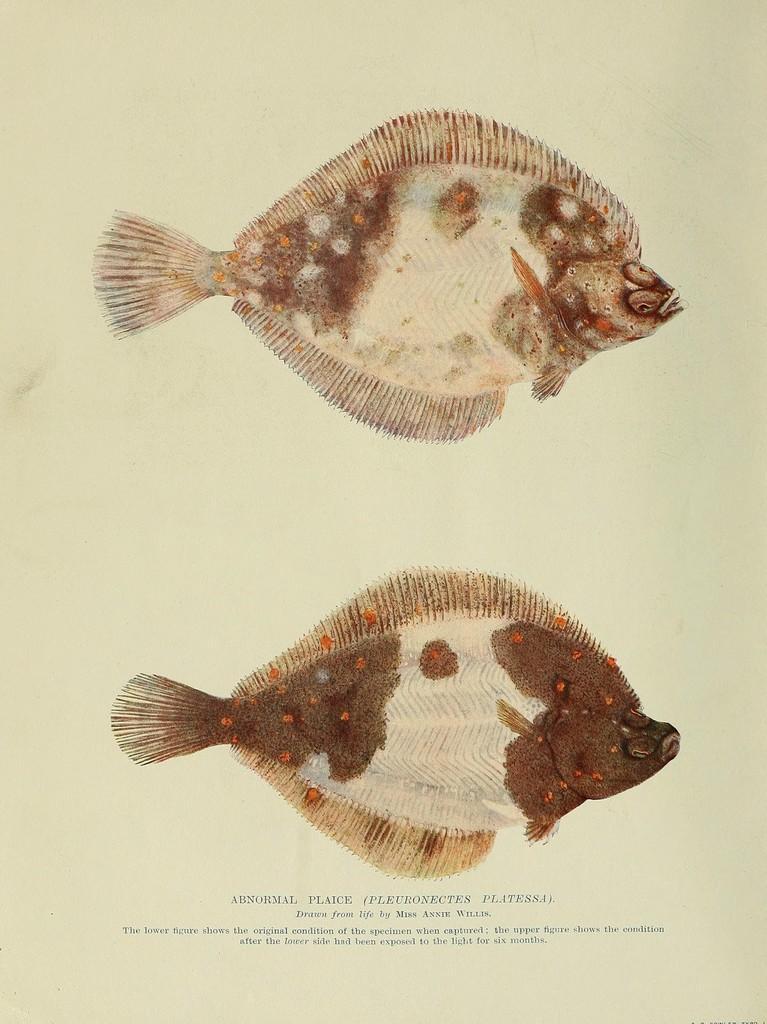In one or two sentences, can you explain what this image depicts? Here we can see a poster. On this posters we can see pictures of fishes and text written on it. 